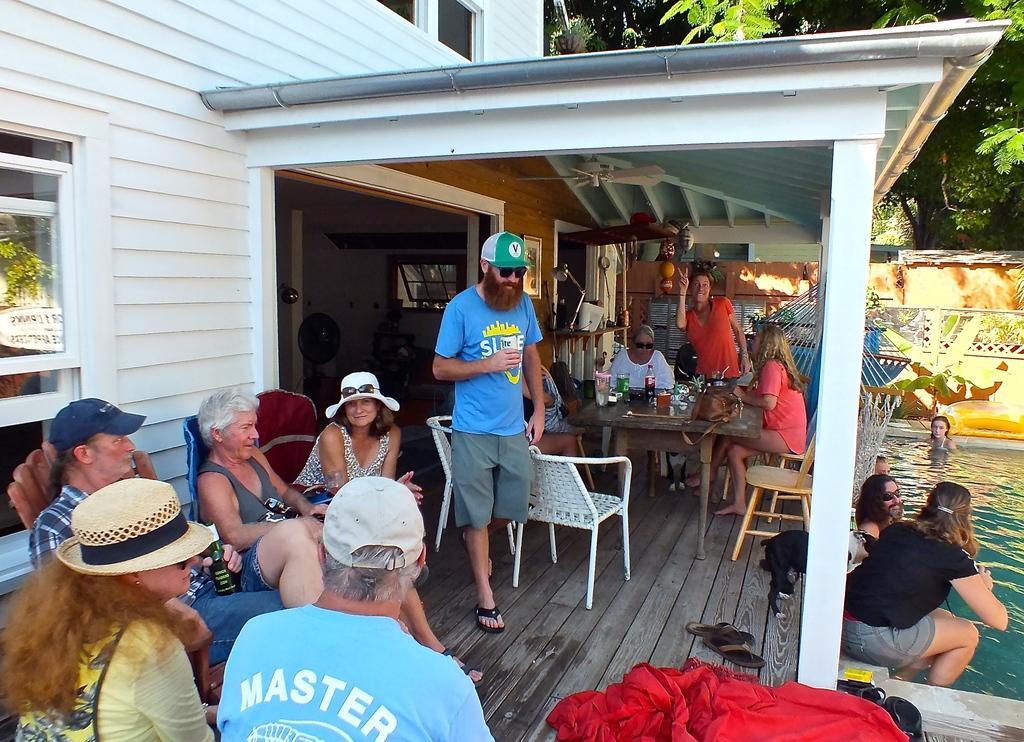In one or two sentences, can you explain what this image depicts? In the image there are few old people sitting on chairs in the front and in the back there are woman sitting in front of table with soft drink glasses on it, on the right side there are people swimming in the pool and behind there is a wall with a tree behind it. 